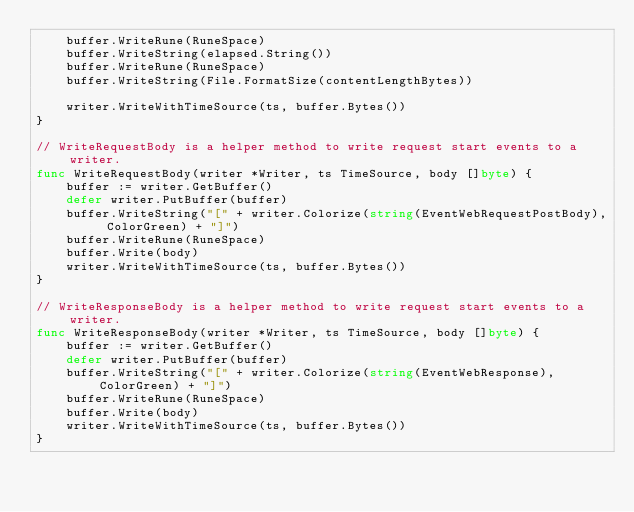Convert code to text. <code><loc_0><loc_0><loc_500><loc_500><_Go_>	buffer.WriteRune(RuneSpace)
	buffer.WriteString(elapsed.String())
	buffer.WriteRune(RuneSpace)
	buffer.WriteString(File.FormatSize(contentLengthBytes))

	writer.WriteWithTimeSource(ts, buffer.Bytes())
}

// WriteRequestBody is a helper method to write request start events to a writer.
func WriteRequestBody(writer *Writer, ts TimeSource, body []byte) {
	buffer := writer.GetBuffer()
	defer writer.PutBuffer(buffer)
	buffer.WriteString("[" + writer.Colorize(string(EventWebRequestPostBody), ColorGreen) + "]")
	buffer.WriteRune(RuneSpace)
	buffer.Write(body)
	writer.WriteWithTimeSource(ts, buffer.Bytes())
}

// WriteResponseBody is a helper method to write request start events to a writer.
func WriteResponseBody(writer *Writer, ts TimeSource, body []byte) {
	buffer := writer.GetBuffer()
	defer writer.PutBuffer(buffer)
	buffer.WriteString("[" + writer.Colorize(string(EventWebResponse), ColorGreen) + "]")
	buffer.WriteRune(RuneSpace)
	buffer.Write(body)
	writer.WriteWithTimeSource(ts, buffer.Bytes())
}
</code> 